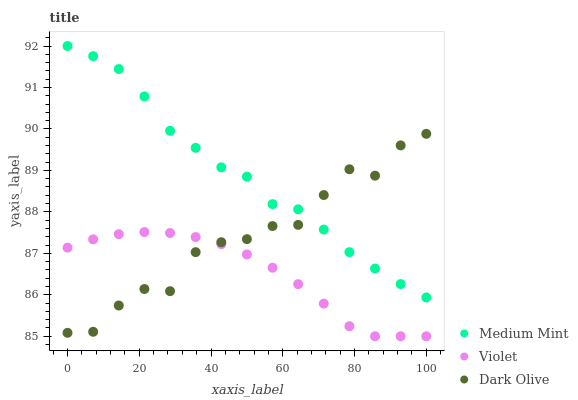Does Violet have the minimum area under the curve?
Answer yes or no. Yes. Does Medium Mint have the maximum area under the curve?
Answer yes or no. Yes. Does Dark Olive have the minimum area under the curve?
Answer yes or no. No. Does Dark Olive have the maximum area under the curve?
Answer yes or no. No. Is Violet the smoothest?
Answer yes or no. Yes. Is Dark Olive the roughest?
Answer yes or no. Yes. Is Dark Olive the smoothest?
Answer yes or no. No. Is Violet the roughest?
Answer yes or no. No. Does Violet have the lowest value?
Answer yes or no. Yes. Does Dark Olive have the lowest value?
Answer yes or no. No. Does Medium Mint have the highest value?
Answer yes or no. Yes. Does Dark Olive have the highest value?
Answer yes or no. No. Is Violet less than Medium Mint?
Answer yes or no. Yes. Is Medium Mint greater than Violet?
Answer yes or no. Yes. Does Dark Olive intersect Violet?
Answer yes or no. Yes. Is Dark Olive less than Violet?
Answer yes or no. No. Is Dark Olive greater than Violet?
Answer yes or no. No. Does Violet intersect Medium Mint?
Answer yes or no. No. 